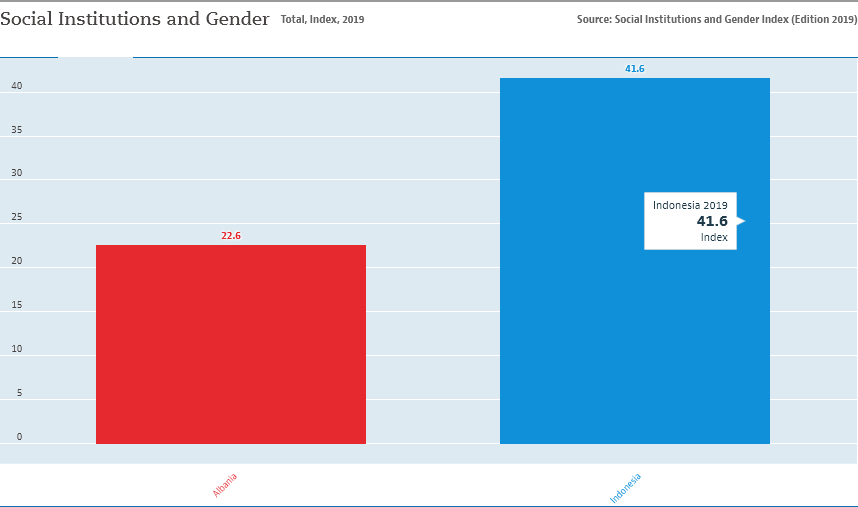Give some essential details in this illustration. What is the distinction between the two bar distribution? 19.. There are two categories in the chart. 